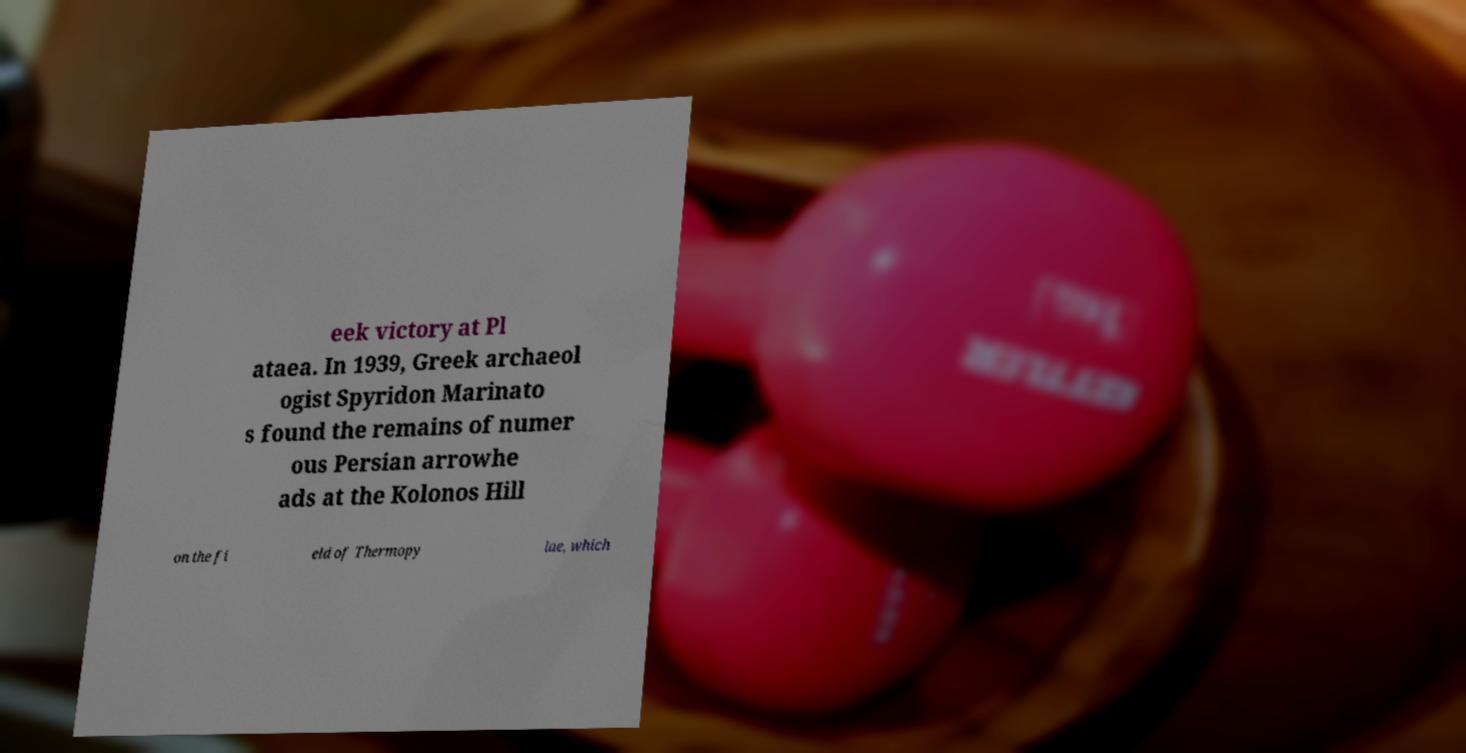Could you extract and type out the text from this image? eek victory at Pl ataea. In 1939, Greek archaeol ogist Spyridon Marinato s found the remains of numer ous Persian arrowhe ads at the Kolonos Hill on the fi eld of Thermopy lae, which 